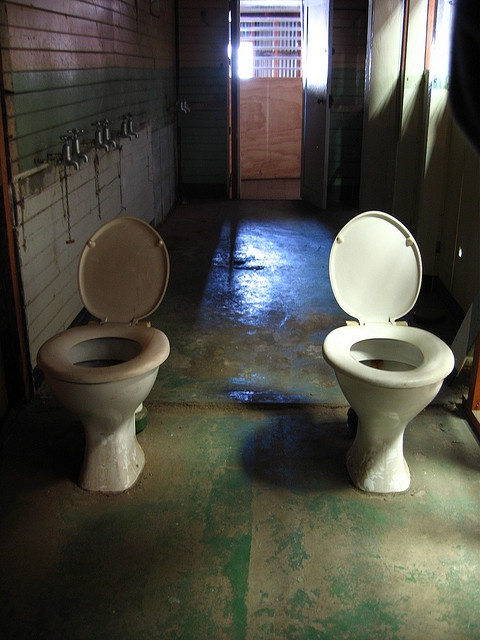Describe the objects in this image and their specific colors. I can see toilet in black, beige, gray, and darkgray tones and toilet in black and gray tones in this image. 